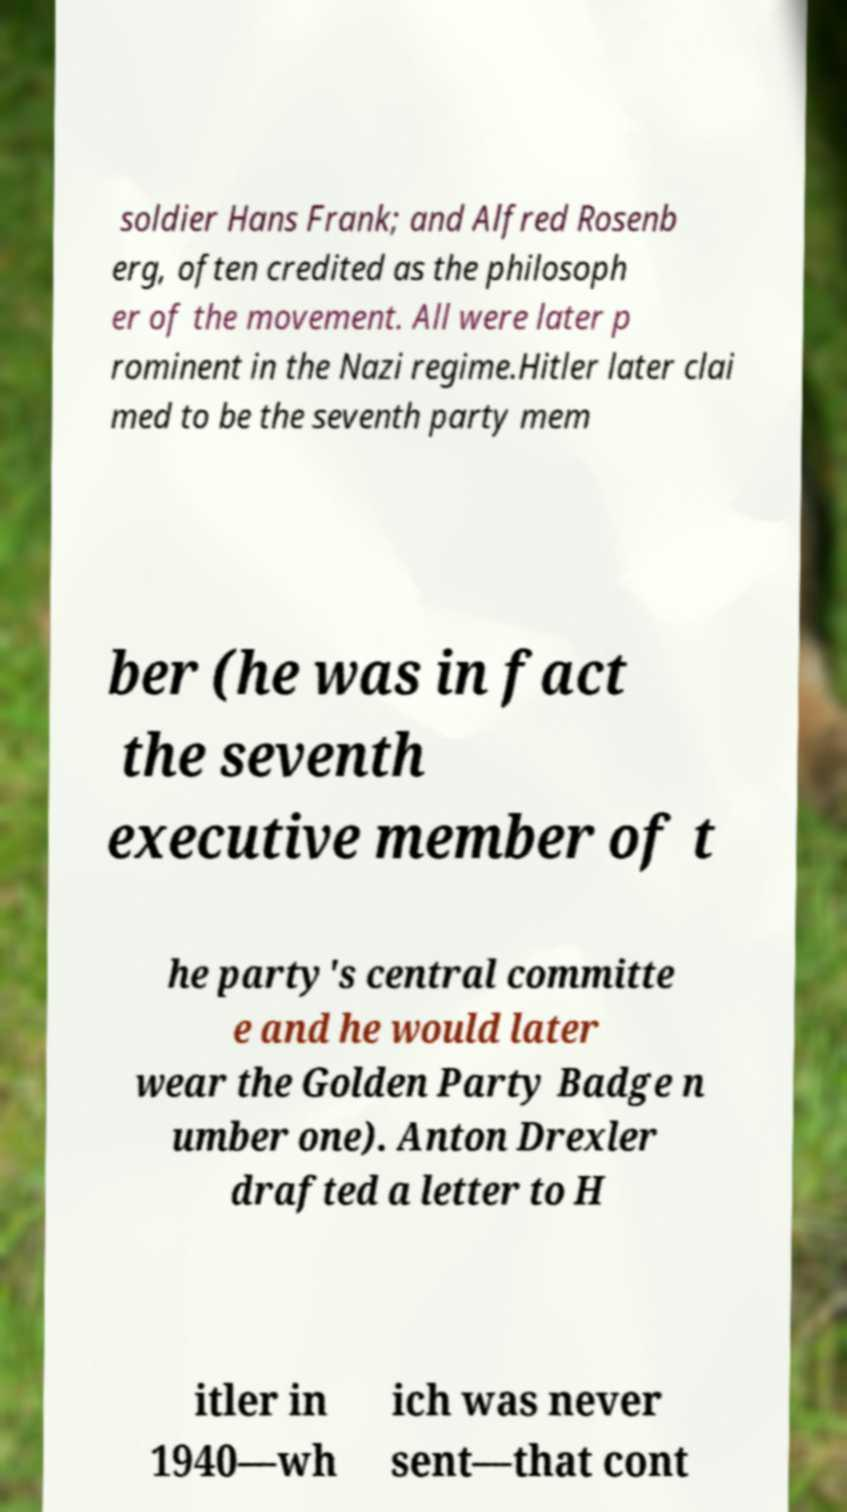Please read and relay the text visible in this image. What does it say? soldier Hans Frank; and Alfred Rosenb erg, often credited as the philosoph er of the movement. All were later p rominent in the Nazi regime.Hitler later clai med to be the seventh party mem ber (he was in fact the seventh executive member of t he party's central committe e and he would later wear the Golden Party Badge n umber one). Anton Drexler drafted a letter to H itler in 1940—wh ich was never sent—that cont 